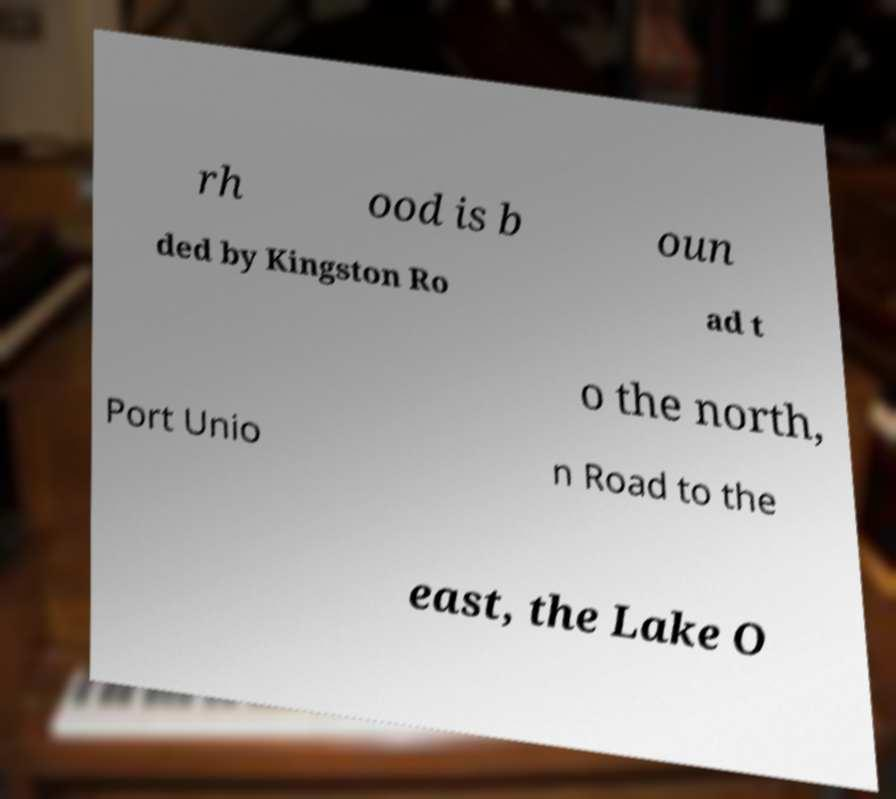What messages or text are displayed in this image? I need them in a readable, typed format. rh ood is b oun ded by Kingston Ro ad t o the north, Port Unio n Road to the east, the Lake O 